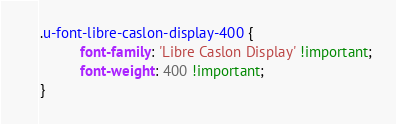Convert code to text. <code><loc_0><loc_0><loc_500><loc_500><_CSS_>.u-font-libre-caslon-display-400 {
          font-family: 'Libre Caslon Display' !important;
          font-weight: 400 !important;
}</code> 